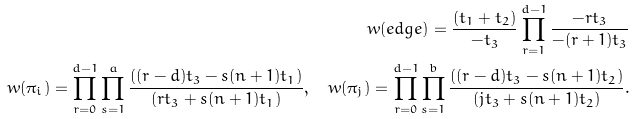Convert formula to latex. <formula><loc_0><loc_0><loc_500><loc_500>w ( e d g e ) = \frac { ( t _ { 1 } + t _ { 2 } ) } { - t _ { 3 } } \prod _ { r = 1 } ^ { d - 1 } \frac { - r t _ { 3 } } { - ( r + 1 ) t _ { 3 } } \\ w ( \pi _ { i } ) = \prod _ { r = 0 } ^ { d - 1 } \prod _ { s = 1 } ^ { a } \frac { ( ( r - d ) t _ { 3 } - s ( n + 1 ) t _ { 1 } ) } { ( r t _ { 3 } + s ( n + 1 ) t _ { 1 } ) } , \quad w ( \pi _ { j } ) = \prod _ { r = 0 } ^ { d - 1 } \prod _ { s = 1 } ^ { b } \frac { ( ( r - d ) t _ { 3 } - s ( n + 1 ) t _ { 2 } ) } { ( j t _ { 3 } + s ( n + 1 ) t _ { 2 } ) } .</formula> 